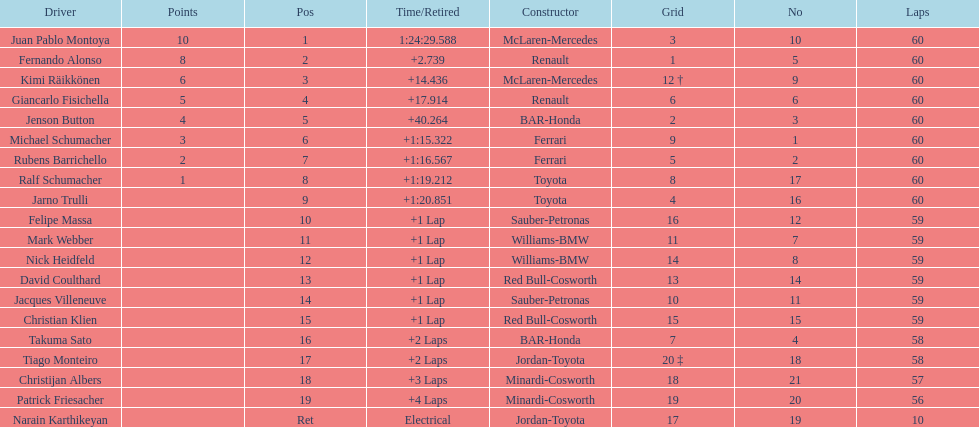Help me parse the entirety of this table. {'header': ['Driver', 'Points', 'Pos', 'Time/Retired', 'Constructor', 'Grid', 'No', 'Laps'], 'rows': [['Juan Pablo Montoya', '10', '1', '1:24:29.588', 'McLaren-Mercedes', '3', '10', '60'], ['Fernando Alonso', '8', '2', '+2.739', 'Renault', '1', '5', '60'], ['Kimi Räikkönen', '6', '3', '+14.436', 'McLaren-Mercedes', '12 †', '9', '60'], ['Giancarlo Fisichella', '5', '4', '+17.914', 'Renault', '6', '6', '60'], ['Jenson Button', '4', '5', '+40.264', 'BAR-Honda', '2', '3', '60'], ['Michael Schumacher', '3', '6', '+1:15.322', 'Ferrari', '9', '1', '60'], ['Rubens Barrichello', '2', '7', '+1:16.567', 'Ferrari', '5', '2', '60'], ['Ralf Schumacher', '1', '8', '+1:19.212', 'Toyota', '8', '17', '60'], ['Jarno Trulli', '', '9', '+1:20.851', 'Toyota', '4', '16', '60'], ['Felipe Massa', '', '10', '+1 Lap', 'Sauber-Petronas', '16', '12', '59'], ['Mark Webber', '', '11', '+1 Lap', 'Williams-BMW', '11', '7', '59'], ['Nick Heidfeld', '', '12', '+1 Lap', 'Williams-BMW', '14', '8', '59'], ['David Coulthard', '', '13', '+1 Lap', 'Red Bull-Cosworth', '13', '14', '59'], ['Jacques Villeneuve', '', '14', '+1 Lap', 'Sauber-Petronas', '10', '11', '59'], ['Christian Klien', '', '15', '+1 Lap', 'Red Bull-Cosworth', '15', '15', '59'], ['Takuma Sato', '', '16', '+2 Laps', 'BAR-Honda', '7', '4', '58'], ['Tiago Monteiro', '', '17', '+2 Laps', 'Jordan-Toyota', '20 ‡', '18', '58'], ['Christijan Albers', '', '18', '+3 Laps', 'Minardi-Cosworth', '18', '21', '57'], ['Patrick Friesacher', '', '19', '+4 Laps', 'Minardi-Cosworth', '19', '20', '56'], ['Narain Karthikeyan', '', 'Ret', 'Electrical', 'Jordan-Toyota', '17', '19', '10']]} Is there a points difference between the 9th position and 19th position on the list? No. 